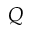<formula> <loc_0><loc_0><loc_500><loc_500>Q</formula> 